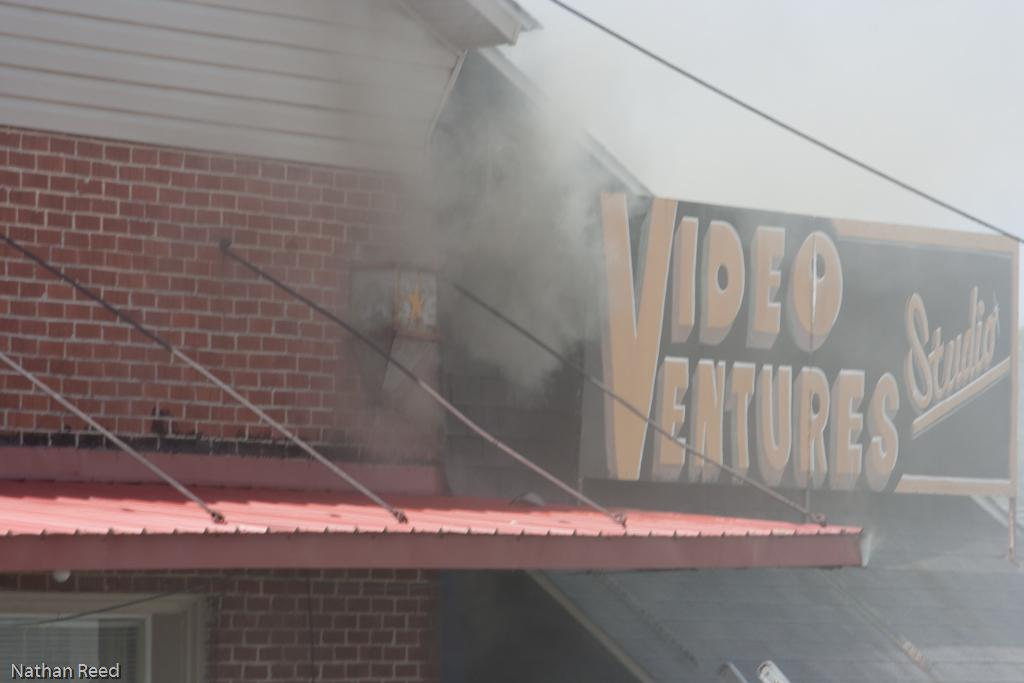What type of structures can be seen in the image? There are buildings in the image. What else is visible in the image besides the buildings? There is smoke visible in the image, as well as a yellow and black board. What can be seen in the background of the image? The sky is visible in the background of the image. What type of marble is being blown around by the wind in the image? There is no marble present in the image, nor is there any wind blowing anything around. 